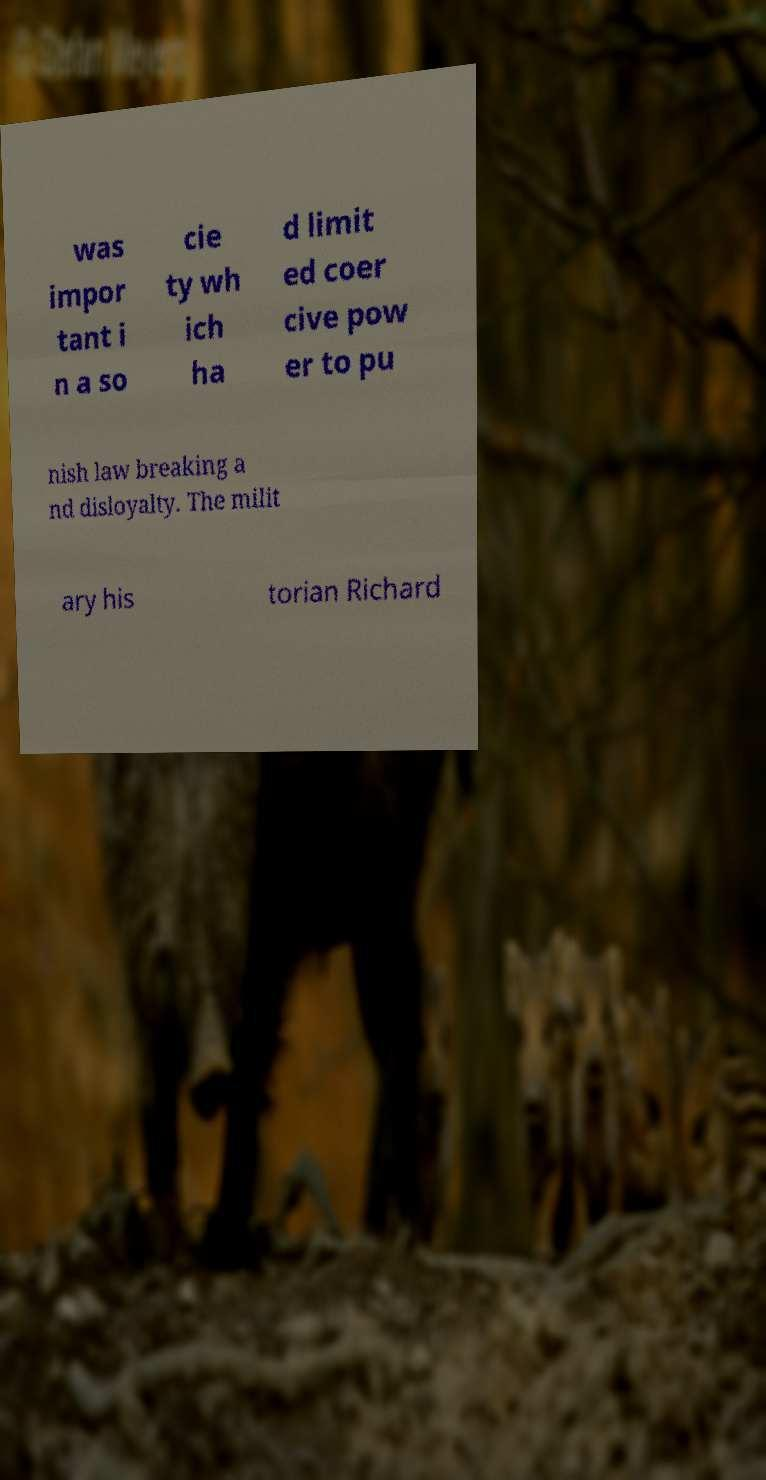Please identify and transcribe the text found in this image. was impor tant i n a so cie ty wh ich ha d limit ed coer cive pow er to pu nish law breaking a nd disloyalty. The milit ary his torian Richard 